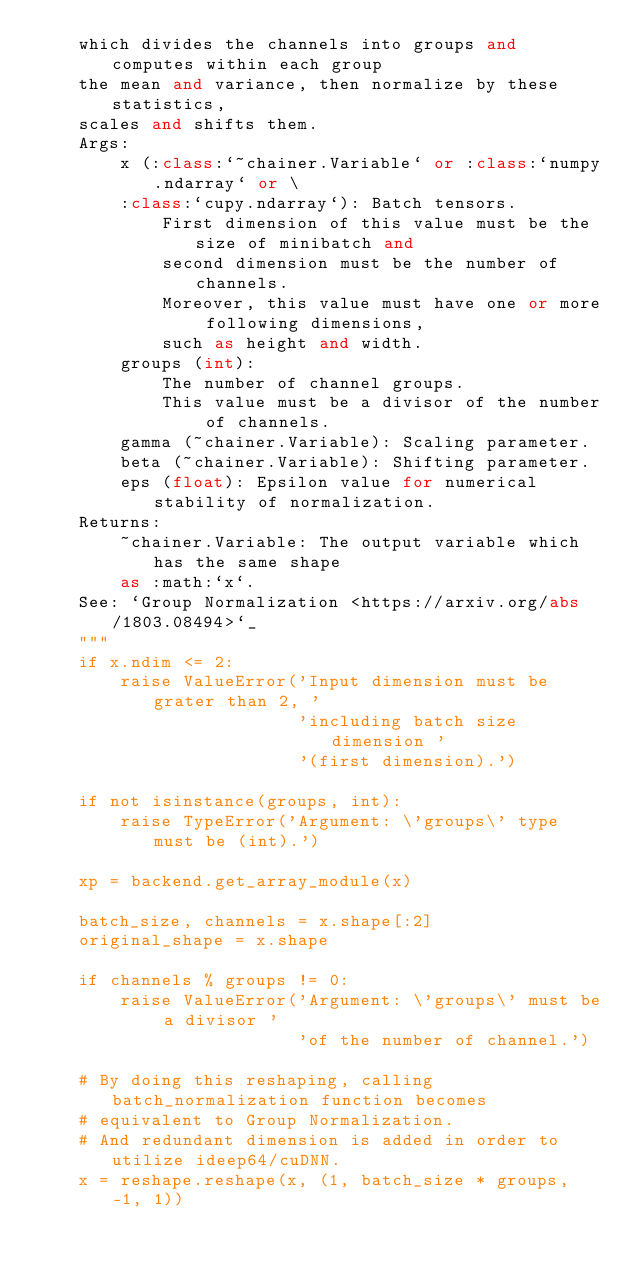<code> <loc_0><loc_0><loc_500><loc_500><_Python_>    which divides the channels into groups and computes within each group
    the mean and variance, then normalize by these statistics,
    scales and shifts them.
    Args:
        x (:class:`~chainer.Variable` or :class:`numpy.ndarray` or \
        :class:`cupy.ndarray`): Batch tensors.
            First dimension of this value must be the size of minibatch and
            second dimension must be the number of channels.
            Moreover, this value must have one or more following dimensions,
            such as height and width.
        groups (int):
            The number of channel groups.
            This value must be a divisor of the number of channels.
        gamma (~chainer.Variable): Scaling parameter.
        beta (~chainer.Variable): Shifting parameter.
        eps (float): Epsilon value for numerical stability of normalization.
    Returns:
        ~chainer.Variable: The output variable which has the same shape
        as :math:`x`.
    See: `Group Normalization <https://arxiv.org/abs/1803.08494>`_
    """
    if x.ndim <= 2:
        raise ValueError('Input dimension must be grater than 2, '
                         'including batch size dimension '
                         '(first dimension).')

    if not isinstance(groups, int):
        raise TypeError('Argument: \'groups\' type must be (int).')

    xp = backend.get_array_module(x)

    batch_size, channels = x.shape[:2]
    original_shape = x.shape

    if channels % groups != 0:
        raise ValueError('Argument: \'groups\' must be a divisor '
                         'of the number of channel.')

    # By doing this reshaping, calling batch_normalization function becomes
    # equivalent to Group Normalization.
    # And redundant dimension is added in order to utilize ideep64/cuDNN.
    x = reshape.reshape(x, (1, batch_size * groups, -1, 1))
</code> 